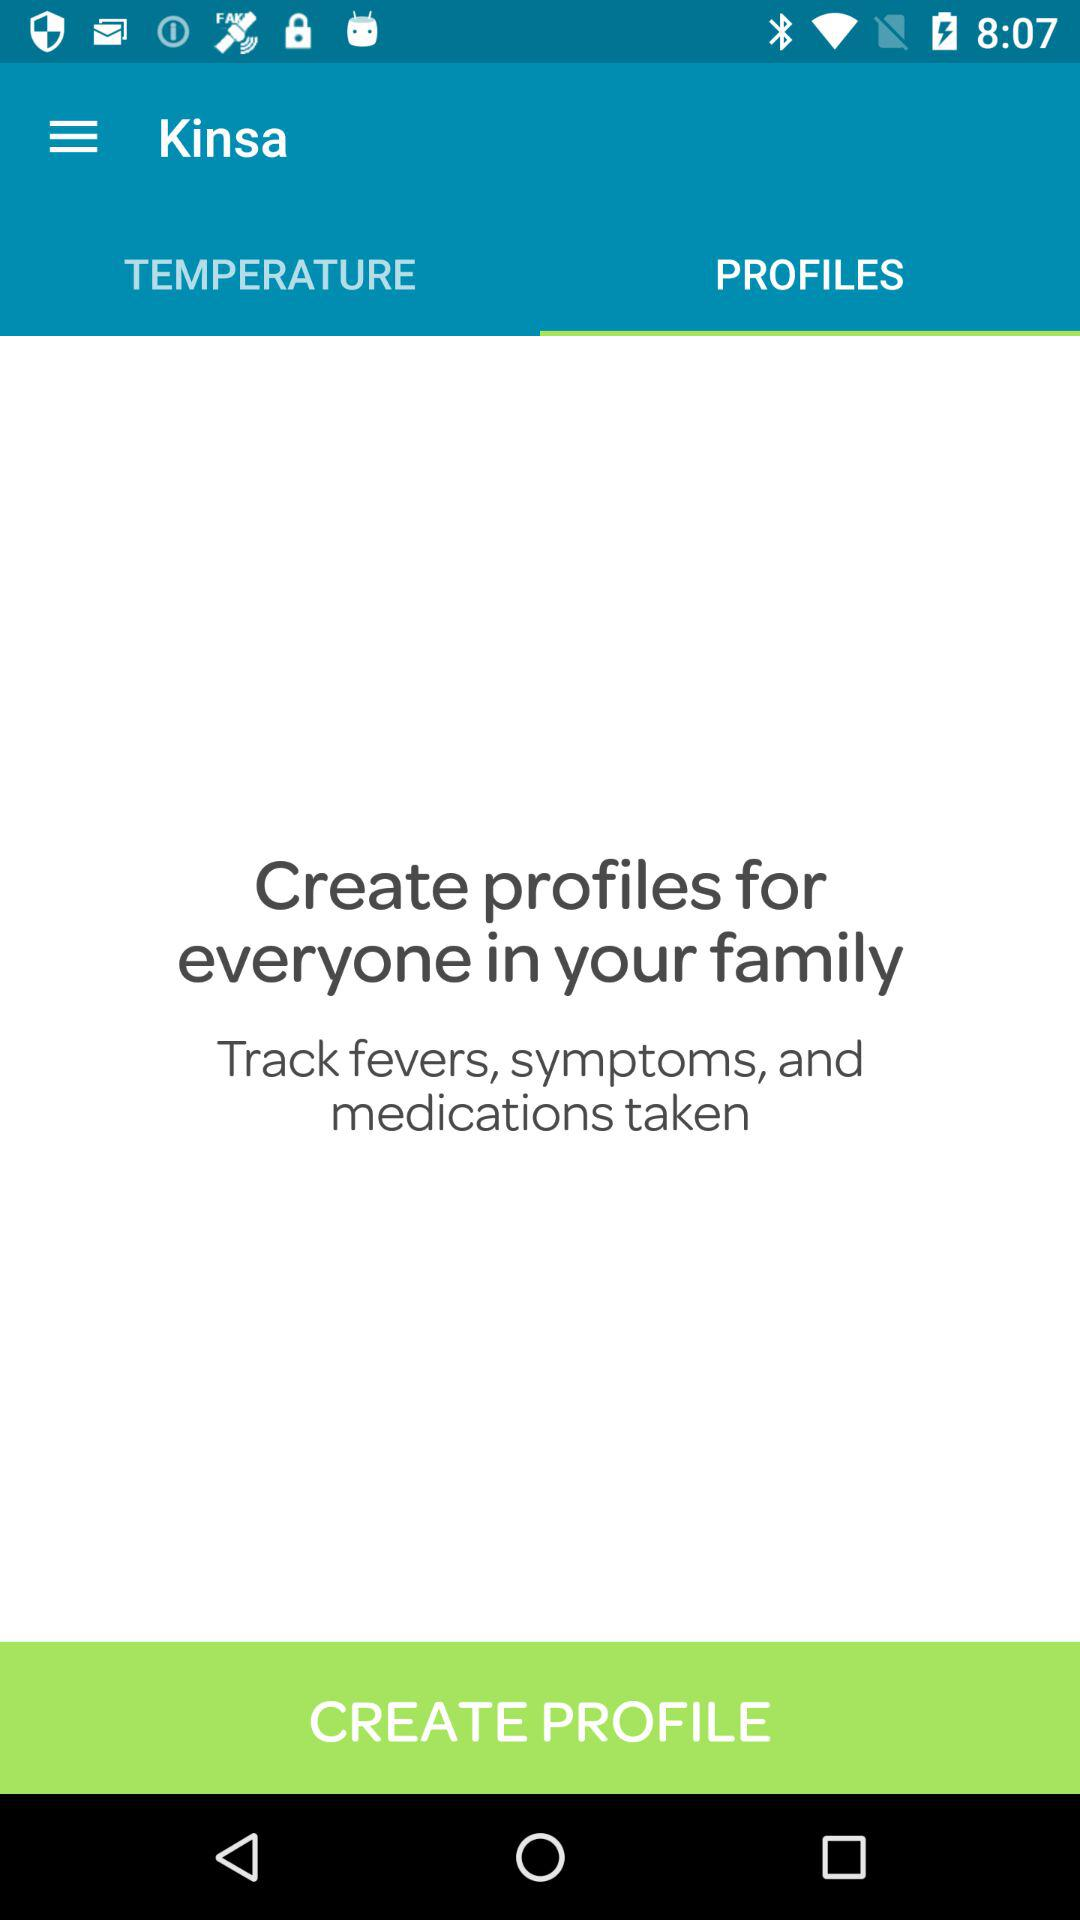Which tab is currently selected? The currently selected tab is "PROFILES". 